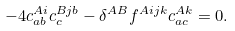<formula> <loc_0><loc_0><loc_500><loc_500>- 4 c _ { a b } ^ { A i } c _ { c } ^ { B j b } - \delta ^ { A B } f ^ { A i j k } c _ { a c } ^ { A k } = 0 .</formula> 